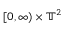Convert formula to latex. <formula><loc_0><loc_0><loc_500><loc_500>[ 0 , \infty ) \times { \mathbb { T } } ^ { 2 }</formula> 